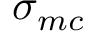Convert formula to latex. <formula><loc_0><loc_0><loc_500><loc_500>\sigma _ { m c }</formula> 